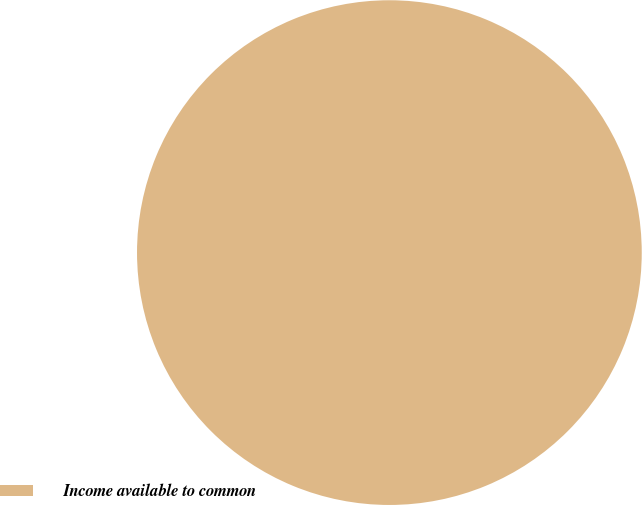Convert chart. <chart><loc_0><loc_0><loc_500><loc_500><pie_chart><fcel>Income available to common<nl><fcel>100.0%<nl></chart> 